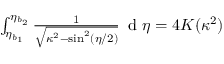Convert formula to latex. <formula><loc_0><loc_0><loc_500><loc_500>\begin{array} { r } { \int _ { \eta _ { b _ { 1 } } } ^ { \eta _ { b _ { 2 } } } \frac { 1 } { \sqrt { \kappa ^ { 2 } - \sin ^ { 2 } ( \eta / 2 ) } } \, d \eta = 4 K ( \kappa ^ { 2 } ) } \end{array}</formula> 